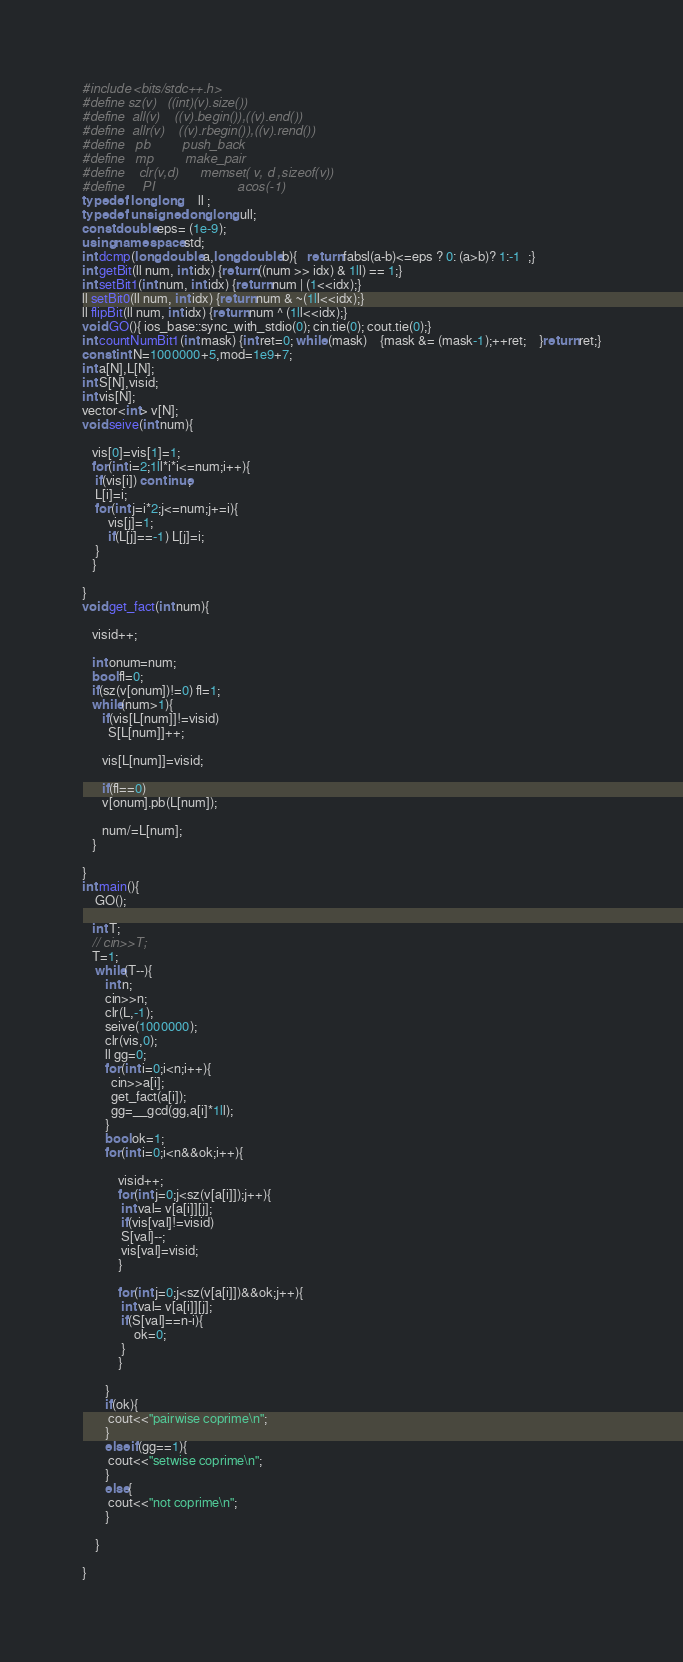Convert code to text. <code><loc_0><loc_0><loc_500><loc_500><_C++_>#include <bits/stdc++.h>
#define sz(v)   ((int)(v).size())
#define  all(v)    ((v).begin()),((v).end())
#define  allr(v)    ((v).rbegin()),((v).rend())
#define   pb         push_back
#define   mp         make_pair
#define    clr(v,d)      memset( v, d ,sizeof(v))
#define     PI                       acos(-1)
typedef  long long     ll ;
typedef  unsigned long long ull;
const double eps= (1e-9);
using namespace std;
int dcmp(long double a,long double b){   return fabsl(a-b)<=eps ? 0: (a>b)? 1:-1  ;}
int getBit(ll num, int idx) {return ((num >> idx) & 1ll) == 1;}
int setBit1(int num, int idx) {return num | (1<<idx);}
ll setBit0(ll num, int idx) {return num & ~(1ll<<idx);}
ll flipBit(ll num, int idx) {return num ^ (1ll<<idx);}
void GO(){ ios_base::sync_with_stdio(0); cin.tie(0); cout.tie(0);}
int countNumBit1(int mask) {int ret=0; while (mask) 	{mask &= (mask-1);++ret;	}return ret;}
const int N=1000000+5,mod=1e9+7;
int a[N],L[N];
int S[N],visid;
int vis[N];
vector<int> v[N];
void seive(int num){

   vis[0]=vis[1]=1;
   for(int i=2;1ll*i*i<=num;i++){
    if(vis[i]) continue;
    L[i]=i;
    for(int j=i*2;j<=num;j+=i){
        vis[j]=1;
        if(L[j]==-1) L[j]=i;
    }
   }

}
void get_fact(int num){

   visid++;

   int onum=num;
   bool fl=0;
   if(sz(v[onum])!=0) fl=1;
   while(num>1){
      if(vis[L[num]]!=visid)
        S[L[num]]++;

      vis[L[num]]=visid;

      if(fl==0)
      v[onum].pb(L[num]);

      num/=L[num];
   }

}
int main(){
    GO();

   int T;
   // cin>>T;
   T=1;
    while(T--){
       int n;
       cin>>n;
       clr(L,-1);
       seive(1000000);
       clr(vis,0);
       ll gg=0;
       for(int i=0;i<n;i++){
         cin>>a[i];
         get_fact(a[i]);
         gg=__gcd(gg,a[i]*1ll);
       }
       bool ok=1;
       for(int i=0;i<n&&ok;i++){

           visid++;
           for(int j=0;j<sz(v[a[i]]);j++){
            int val= v[a[i]][j];
            if(vis[val]!=visid)
            S[val]--;
            vis[val]=visid;
           }

           for(int j=0;j<sz(v[a[i]])&&ok;j++){
            int val= v[a[i]][j];
            if(S[val]==n-i){
                ok=0;
            }
           }

       }
       if(ok){
        cout<<"pairwise coprime\n";
       }
       else if(gg==1){
        cout<<"setwise coprime\n";
       }
       else{
        cout<<"not coprime\n";
       }

    }

}



































































</code> 